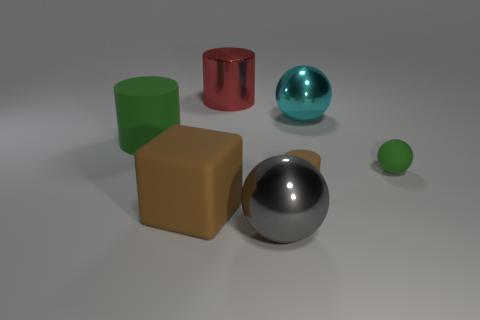There is a shiny ball that is on the left side of the large cyan shiny thing; is it the same size as the shiny sphere to the right of the small matte cylinder?
Give a very brief answer. Yes. How many objects are either metallic things that are behind the gray metal thing or rubber things behind the large brown rubber object?
Offer a terse response. 5. Is there anything else that is the same shape as the large brown object?
Ensure brevity in your answer.  No. There is a small object behind the tiny rubber cylinder; is it the same color as the matte cylinder left of the gray metallic thing?
Your answer should be compact. Yes. What number of matte objects are either brown things or big cylinders?
Provide a short and direct response. 3. The small rubber object in front of the green matte thing that is right of the gray metal thing is what shape?
Your response must be concise. Cylinder. Do the big sphere behind the tiny green object and the sphere to the left of the cyan sphere have the same material?
Give a very brief answer. Yes. There is a ball in front of the small matte sphere; what number of big brown blocks are to the right of it?
Offer a terse response. 0. There is a green object on the left side of the big gray ball; is it the same shape as the brown matte thing that is right of the gray shiny object?
Offer a terse response. Yes. There is a rubber thing that is right of the large brown block and on the left side of the big cyan shiny thing; what size is it?
Keep it short and to the point. Small. 